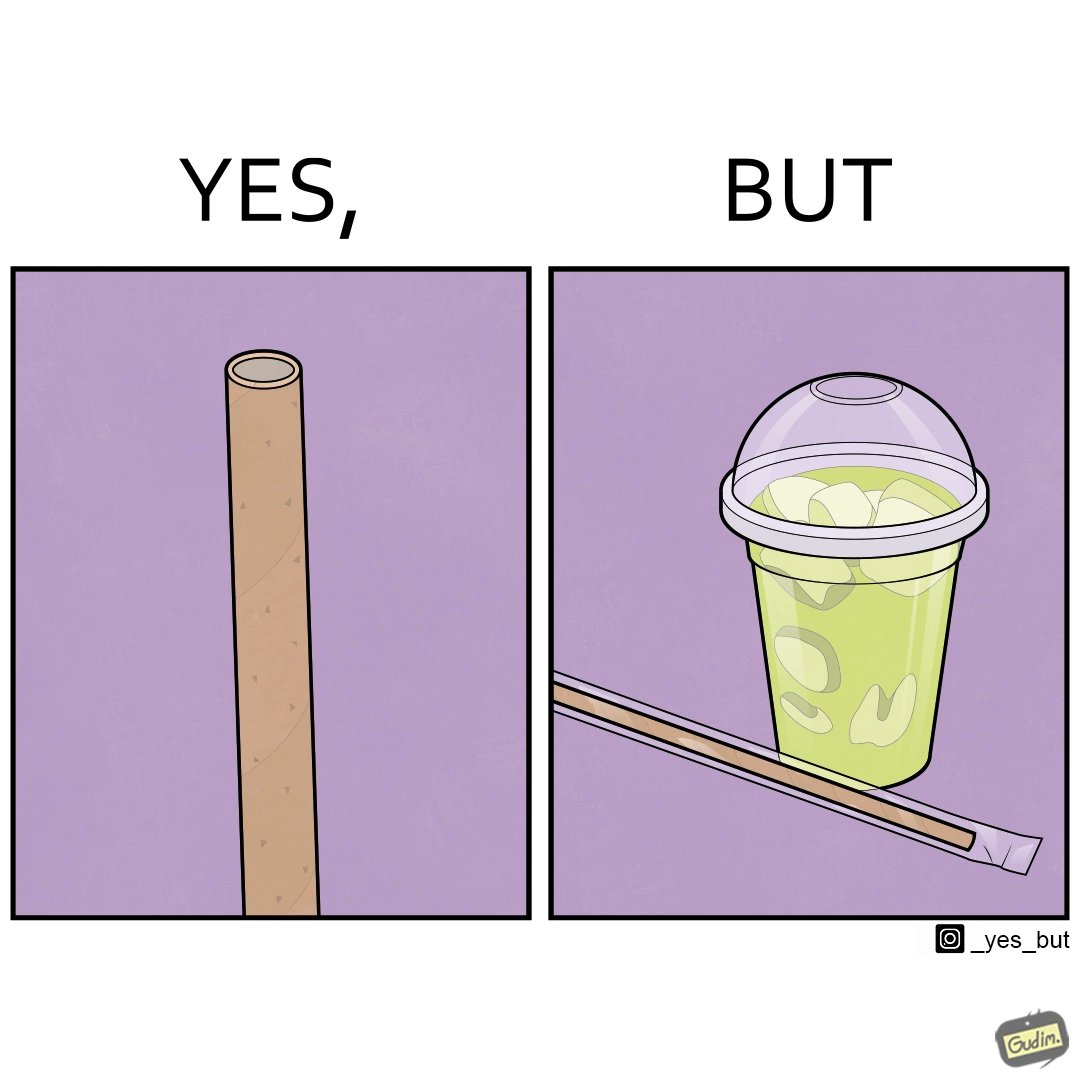Explain why this image is satirical. The images are ironic since paper straws were invented to reduce use of plastic in the form of plastic straws. However, these straws come in plastic packages and are served with plastic cups, defeating  the purpose 